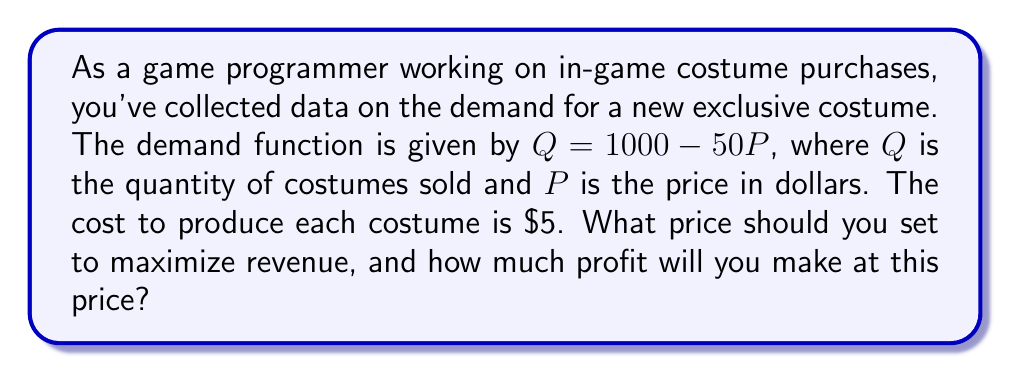Help me with this question. To solve this problem, we'll follow these steps:

1) First, let's find the revenue function. Revenue is price times quantity:
   $R = PQ = P(1000 - 50P) = 1000P - 50P^2$

2) To maximize revenue, we need to find where the derivative of the revenue function equals zero:
   $\frac{dR}{dP} = 1000 - 100P$
   Set this equal to zero:
   $1000 - 100P = 0$
   $100P = 1000$
   $P = 10$

3) To confirm this is a maximum, we can check the second derivative:
   $\frac{d^2R}{dP^2} = -100$, which is negative, confirming a maximum.

4) Now we know the revenue-maximizing price is $10. Let's calculate the quantity sold at this price:
   $Q = 1000 - 50(10) = 500$

5) Revenue at this price is:
   $R = 10 * 500 = 5000$

6) To calculate profit, we need to subtract costs:
   Cost per unit is $5, and we're selling 500 units.
   Total cost = $5 * 500 = 2500$
   Profit = Revenue - Cost = $5000 - $2500 = $2500$

Therefore, to maximize revenue, you should set the price at $10. At this price, you'll sell 500 costumes and make a profit of $2500.
Answer: Set the price at $10. The maximum profit will be $2500. 